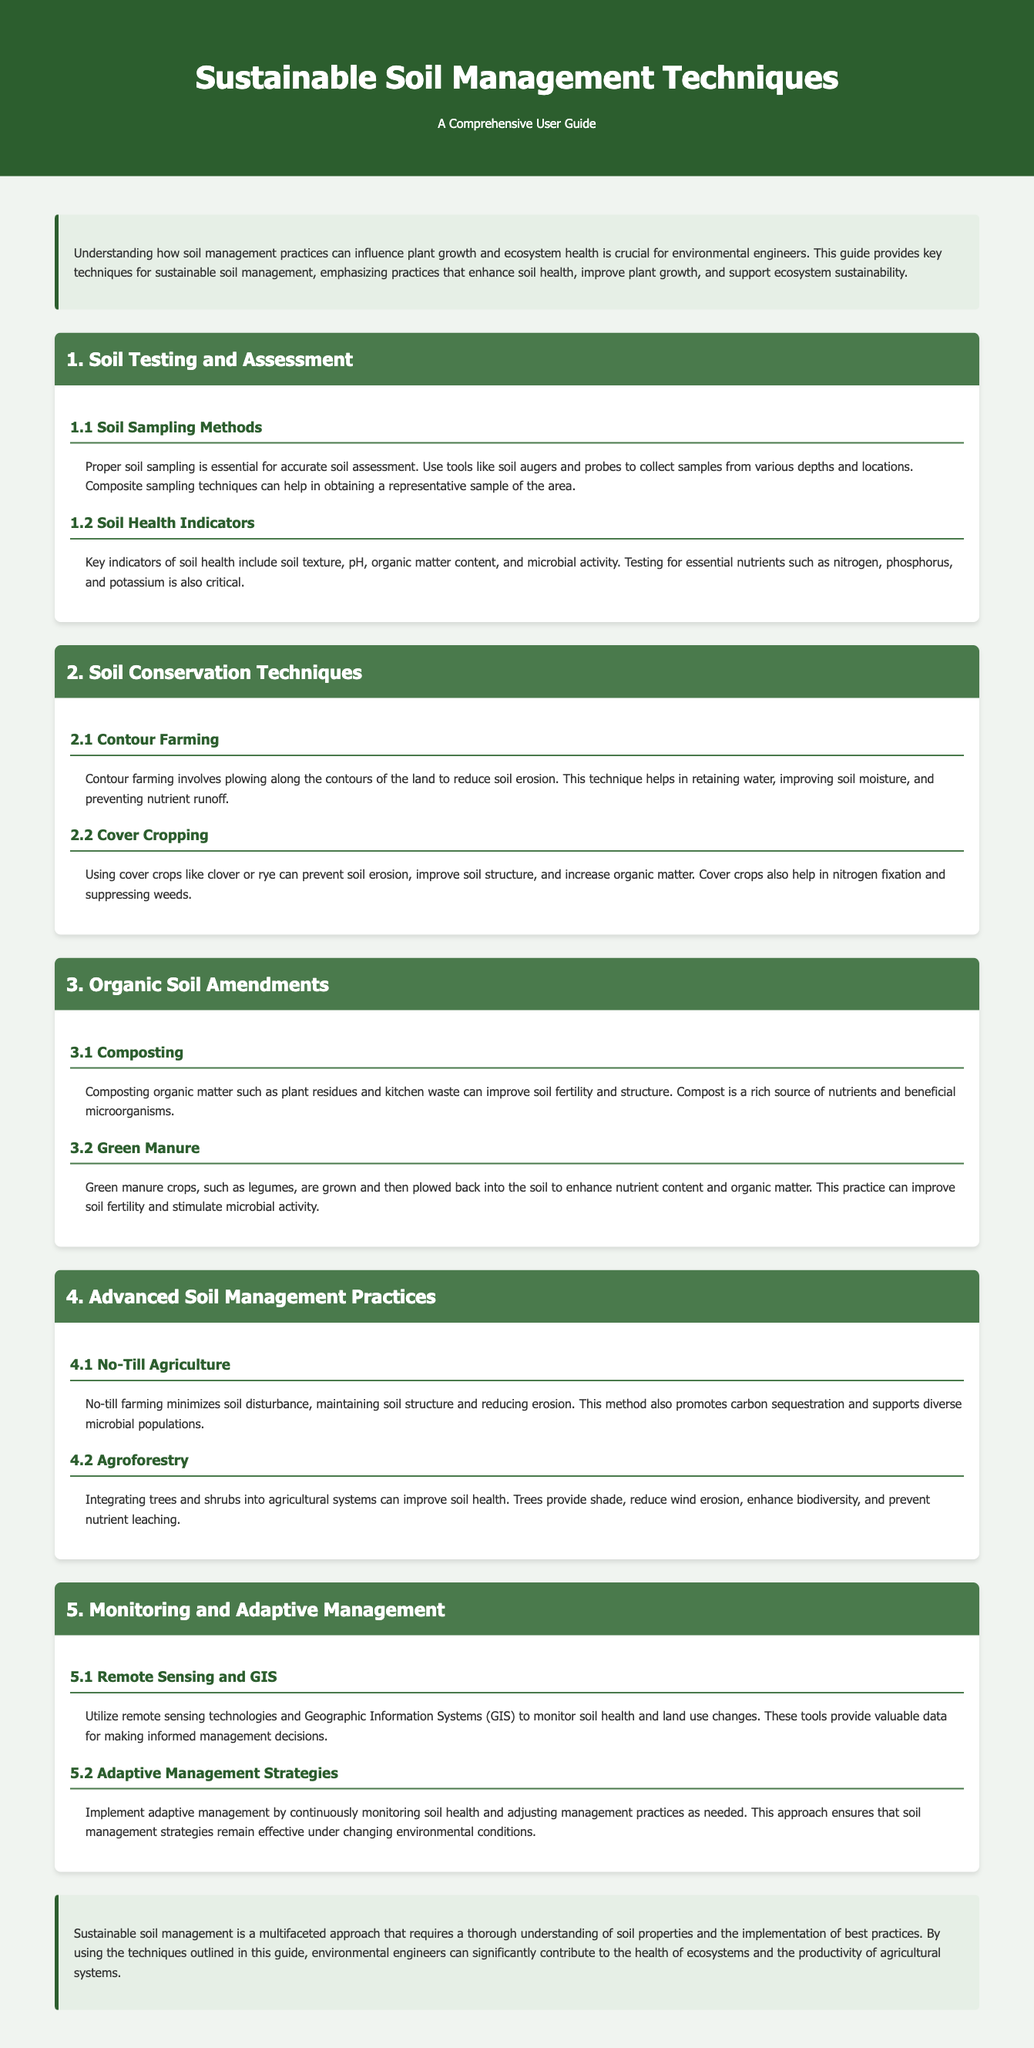What is the title of the guide? The title of the guide is explicitly mentioned at the top of the document.
Answer: Sustainable Soil Management Techniques: A Comprehensive User Guide What are two indicators of soil health? The document lists key indicators of soil health under the subsection about soil health indicators.
Answer: pH, organic matter content What technique helps in reducing soil erosion? The document discusses various soil conservation techniques, specifically indicating one of them.
Answer: Contour Farming What is one benefit of using cover crops? The details under the cover cropping subsection outline the advantages of this practice.
Answer: Preventing soil erosion What advanced soil management practice promotes carbon sequestration? The document describes no-till farming as one of the advanced practices that support this.
Answer: No-Till Agriculture What method is mentioned for soil sampling? The guide includes specific tools and methods for collecting soil samples.
Answer: Soil augers and probes What is a purpose of composting? The composting subsection states its benefits related to soil fertility.
Answer: Improve soil fertility Which technology is suggested for monitoring soil health? The document mentions specific technologies for monitoring in the relevant section.
Answer: Remote sensing technologies How should management practices be adjusted according to the guide? The document provides advice on modifying practices based on ongoing assessments.
Answer: Continuously monitoring soil health 